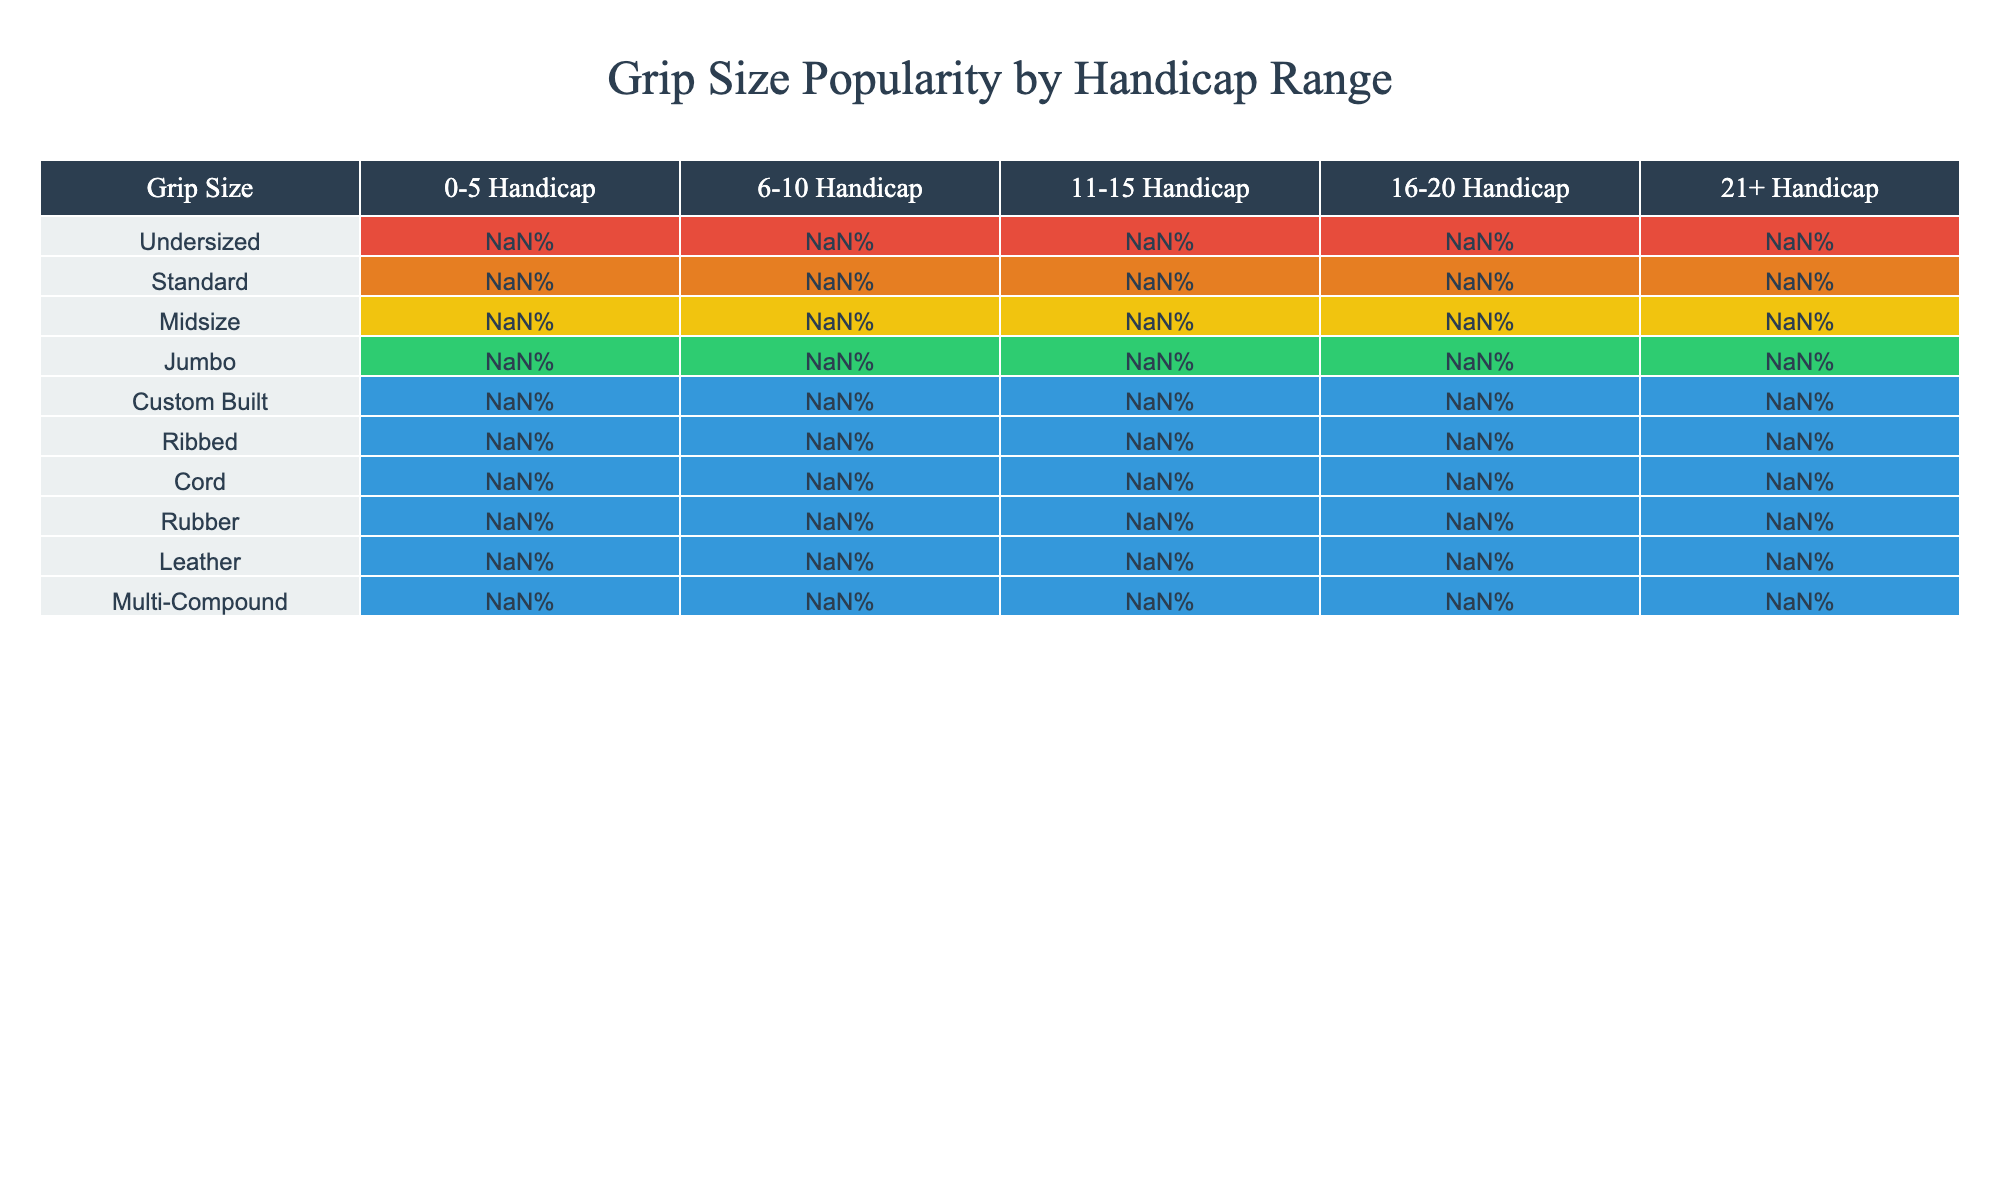What is the most popular grip size among golfers with a handicap of 0-5? Looking at the row for the 0-5 handicap, the grip size with the highest percentage is the Standard grip size at 45%.
Answer: 45% Which grip size is least popular among golfers with a handicap of 21+? In the row for the 21+ handicap, the grip size with the lowest percentage is the Custom Built grip size at 1%.
Answer: 1% What grip size has a popularity percentage of 60% for golfers with a 16-20 handicap? Referring to the 16-20 handicap row, the grip size with a 60% popularity is the Standard grip size.
Answer: Standard What is the average popularity of the Rubber grip size across all handicap ranges? The percentages for the Rubber grip size are 60%, 65%, 70%, 75%, and 80%. The sum is 350%, and dividing by 5 gives an average of 70%.
Answer: 70% Which grip size is more popular among the 11-15 handicap range: Midsize or Cord? In the 11-15 handicap range, Midsize has a popularity of 25% while Cord has 20%. Midsize is more popular.
Answer: Midsize Are golfers with a 21+ handicap more likely to prefer Cord grips than those with a 16-20 handicap? For the 21+ handicap, the popularity of Cord grips is 10%, while for the 16-20 handicap, it's 15%. 21+ handicap golfers prefer Cord grips less.
Answer: No What is the difference in popularity between Undersized and Jumbo grips for golfers with a 6-10 handicap? In the 6-10 handicap range, the Undersized grip has an 8% popularity while Jumbo has 12%. The difference is 12% - 8% = 4%.
Answer: 4% Considering all handicap ranges, what grip size has the highest overall percentage? By examining the table, the Rubber grip size consistently holds the highest percentages across all handicap ranges, particularly 60% at the lowest range and 80% at the highest.
Answer: Rubber If a player with a 16-20 handicap chooses a Ribbed grip, what percentage of golfers in that range would prefer it? The popularity percentage for Ribbed grips in the 16-20 handicap range is 10%. This means 10% of golfers in that range prefer Ribbed grips.
Answer: 10% Which two grip sizes have the same popularity among 11-15 handicappers, and what is that percentage? In the 11-15 handicap range, both Midsize and Cord grips have popularity percentages of 25% and 20%, respectively, but the same percentage is for Midsize - 25%.
Answer: Midsize at 25% 